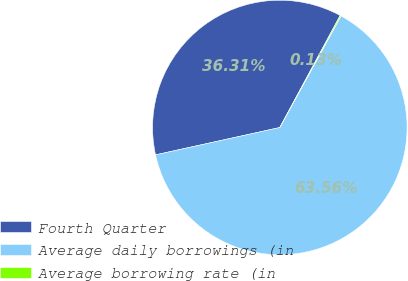<chart> <loc_0><loc_0><loc_500><loc_500><pie_chart><fcel>Fourth Quarter<fcel>Average daily borrowings (in<fcel>Average borrowing rate (in<nl><fcel>36.31%<fcel>63.56%<fcel>0.13%<nl></chart> 